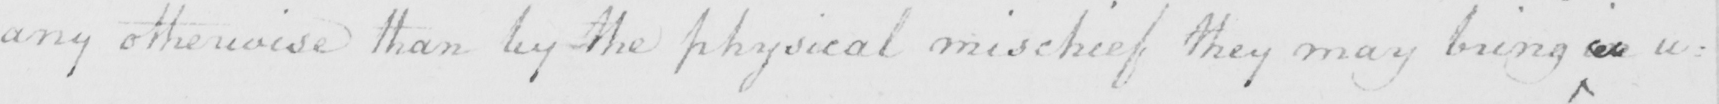Can you read and transcribe this handwriting? any otherwise than by the physical mischief they may bring on u= 